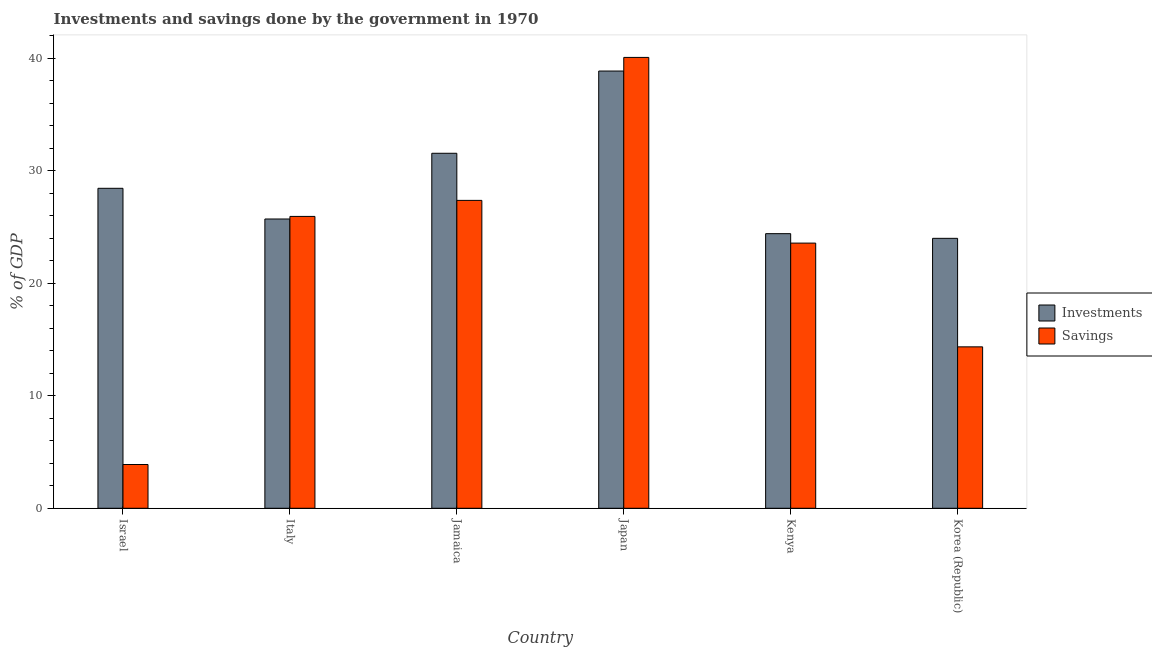How many different coloured bars are there?
Your response must be concise. 2. How many bars are there on the 3rd tick from the right?
Ensure brevity in your answer.  2. What is the label of the 1st group of bars from the left?
Offer a very short reply. Israel. In how many cases, is the number of bars for a given country not equal to the number of legend labels?
Your answer should be compact. 0. What is the savings of government in Japan?
Your answer should be compact. 40.05. Across all countries, what is the maximum savings of government?
Your answer should be very brief. 40.05. Across all countries, what is the minimum savings of government?
Give a very brief answer. 3.89. In which country was the savings of government maximum?
Offer a terse response. Japan. What is the total savings of government in the graph?
Provide a short and direct response. 135.13. What is the difference between the investments of government in Japan and that in Kenya?
Ensure brevity in your answer.  14.45. What is the difference between the investments of government in Japan and the savings of government in Jamaica?
Your answer should be compact. 11.49. What is the average savings of government per country?
Make the answer very short. 22.52. What is the difference between the savings of government and investments of government in Korea (Republic)?
Your response must be concise. -9.64. What is the ratio of the savings of government in Israel to that in Kenya?
Offer a terse response. 0.17. What is the difference between the highest and the second highest investments of government?
Give a very brief answer. 7.31. What is the difference between the highest and the lowest investments of government?
Your answer should be very brief. 14.86. Is the sum of the savings of government in Italy and Kenya greater than the maximum investments of government across all countries?
Make the answer very short. Yes. What does the 1st bar from the left in Kenya represents?
Keep it short and to the point. Investments. What does the 1st bar from the right in Italy represents?
Give a very brief answer. Savings. How many bars are there?
Your answer should be very brief. 12. Are all the bars in the graph horizontal?
Offer a very short reply. No. How many countries are there in the graph?
Your answer should be very brief. 6. Are the values on the major ticks of Y-axis written in scientific E-notation?
Your answer should be very brief. No. How are the legend labels stacked?
Offer a terse response. Vertical. What is the title of the graph?
Provide a succinct answer. Investments and savings done by the government in 1970. What is the label or title of the Y-axis?
Your answer should be very brief. % of GDP. What is the % of GDP in Investments in Israel?
Ensure brevity in your answer.  28.43. What is the % of GDP in Savings in Israel?
Offer a very short reply. 3.89. What is the % of GDP of Investments in Italy?
Your response must be concise. 25.7. What is the % of GDP of Savings in Italy?
Provide a short and direct response. 25.93. What is the % of GDP of Investments in Jamaica?
Keep it short and to the point. 31.54. What is the % of GDP in Savings in Jamaica?
Ensure brevity in your answer.  27.35. What is the % of GDP of Investments in Japan?
Offer a very short reply. 38.84. What is the % of GDP in Savings in Japan?
Keep it short and to the point. 40.05. What is the % of GDP in Investments in Kenya?
Ensure brevity in your answer.  24.4. What is the % of GDP in Savings in Kenya?
Offer a terse response. 23.56. What is the % of GDP in Investments in Korea (Republic)?
Give a very brief answer. 23.98. What is the % of GDP in Savings in Korea (Republic)?
Ensure brevity in your answer.  14.34. Across all countries, what is the maximum % of GDP in Investments?
Keep it short and to the point. 38.84. Across all countries, what is the maximum % of GDP of Savings?
Make the answer very short. 40.05. Across all countries, what is the minimum % of GDP of Investments?
Offer a terse response. 23.98. Across all countries, what is the minimum % of GDP in Savings?
Offer a very short reply. 3.89. What is the total % of GDP of Investments in the graph?
Your response must be concise. 172.89. What is the total % of GDP of Savings in the graph?
Make the answer very short. 135.13. What is the difference between the % of GDP in Investments in Israel and that in Italy?
Your answer should be very brief. 2.73. What is the difference between the % of GDP of Savings in Israel and that in Italy?
Offer a very short reply. -22.04. What is the difference between the % of GDP in Investments in Israel and that in Jamaica?
Offer a terse response. -3.11. What is the difference between the % of GDP in Savings in Israel and that in Jamaica?
Offer a very short reply. -23.47. What is the difference between the % of GDP of Investments in Israel and that in Japan?
Keep it short and to the point. -10.42. What is the difference between the % of GDP of Savings in Israel and that in Japan?
Provide a short and direct response. -36.17. What is the difference between the % of GDP of Investments in Israel and that in Kenya?
Your response must be concise. 4.03. What is the difference between the % of GDP of Savings in Israel and that in Kenya?
Make the answer very short. -19.67. What is the difference between the % of GDP in Investments in Israel and that in Korea (Republic)?
Give a very brief answer. 4.45. What is the difference between the % of GDP of Savings in Israel and that in Korea (Republic)?
Provide a succinct answer. -10.45. What is the difference between the % of GDP of Investments in Italy and that in Jamaica?
Provide a succinct answer. -5.84. What is the difference between the % of GDP of Savings in Italy and that in Jamaica?
Give a very brief answer. -1.42. What is the difference between the % of GDP in Investments in Italy and that in Japan?
Provide a short and direct response. -13.14. What is the difference between the % of GDP of Savings in Italy and that in Japan?
Your answer should be very brief. -14.12. What is the difference between the % of GDP in Investments in Italy and that in Kenya?
Provide a succinct answer. 1.3. What is the difference between the % of GDP of Savings in Italy and that in Kenya?
Offer a very short reply. 2.37. What is the difference between the % of GDP of Investments in Italy and that in Korea (Republic)?
Provide a succinct answer. 1.72. What is the difference between the % of GDP of Savings in Italy and that in Korea (Republic)?
Ensure brevity in your answer.  11.59. What is the difference between the % of GDP of Investments in Jamaica and that in Japan?
Keep it short and to the point. -7.31. What is the difference between the % of GDP of Savings in Jamaica and that in Japan?
Offer a very short reply. -12.7. What is the difference between the % of GDP of Investments in Jamaica and that in Kenya?
Offer a very short reply. 7.14. What is the difference between the % of GDP in Savings in Jamaica and that in Kenya?
Your answer should be very brief. 3.79. What is the difference between the % of GDP of Investments in Jamaica and that in Korea (Republic)?
Give a very brief answer. 7.56. What is the difference between the % of GDP of Savings in Jamaica and that in Korea (Republic)?
Offer a very short reply. 13.01. What is the difference between the % of GDP of Investments in Japan and that in Kenya?
Keep it short and to the point. 14.45. What is the difference between the % of GDP in Savings in Japan and that in Kenya?
Provide a short and direct response. 16.5. What is the difference between the % of GDP of Investments in Japan and that in Korea (Republic)?
Provide a short and direct response. 14.86. What is the difference between the % of GDP in Savings in Japan and that in Korea (Republic)?
Give a very brief answer. 25.71. What is the difference between the % of GDP in Investments in Kenya and that in Korea (Republic)?
Offer a very short reply. 0.42. What is the difference between the % of GDP in Savings in Kenya and that in Korea (Republic)?
Offer a terse response. 9.22. What is the difference between the % of GDP of Investments in Israel and the % of GDP of Savings in Italy?
Provide a short and direct response. 2.5. What is the difference between the % of GDP in Investments in Israel and the % of GDP in Savings in Jamaica?
Give a very brief answer. 1.07. What is the difference between the % of GDP of Investments in Israel and the % of GDP of Savings in Japan?
Your answer should be very brief. -11.63. What is the difference between the % of GDP of Investments in Israel and the % of GDP of Savings in Kenya?
Provide a succinct answer. 4.87. What is the difference between the % of GDP of Investments in Israel and the % of GDP of Savings in Korea (Republic)?
Your answer should be compact. 14.08. What is the difference between the % of GDP in Investments in Italy and the % of GDP in Savings in Jamaica?
Provide a short and direct response. -1.65. What is the difference between the % of GDP of Investments in Italy and the % of GDP of Savings in Japan?
Ensure brevity in your answer.  -14.36. What is the difference between the % of GDP in Investments in Italy and the % of GDP in Savings in Kenya?
Your answer should be compact. 2.14. What is the difference between the % of GDP in Investments in Italy and the % of GDP in Savings in Korea (Republic)?
Ensure brevity in your answer.  11.36. What is the difference between the % of GDP of Investments in Jamaica and the % of GDP of Savings in Japan?
Make the answer very short. -8.52. What is the difference between the % of GDP of Investments in Jamaica and the % of GDP of Savings in Kenya?
Keep it short and to the point. 7.98. What is the difference between the % of GDP in Investments in Jamaica and the % of GDP in Savings in Korea (Republic)?
Your answer should be compact. 17.2. What is the difference between the % of GDP of Investments in Japan and the % of GDP of Savings in Kenya?
Ensure brevity in your answer.  15.29. What is the difference between the % of GDP in Investments in Japan and the % of GDP in Savings in Korea (Republic)?
Offer a terse response. 24.5. What is the difference between the % of GDP of Investments in Kenya and the % of GDP of Savings in Korea (Republic)?
Give a very brief answer. 10.06. What is the average % of GDP of Investments per country?
Give a very brief answer. 28.81. What is the average % of GDP in Savings per country?
Your answer should be compact. 22.52. What is the difference between the % of GDP in Investments and % of GDP in Savings in Israel?
Your answer should be very brief. 24.54. What is the difference between the % of GDP of Investments and % of GDP of Savings in Italy?
Give a very brief answer. -0.23. What is the difference between the % of GDP in Investments and % of GDP in Savings in Jamaica?
Your response must be concise. 4.19. What is the difference between the % of GDP of Investments and % of GDP of Savings in Japan?
Your answer should be very brief. -1.21. What is the difference between the % of GDP of Investments and % of GDP of Savings in Kenya?
Make the answer very short. 0.84. What is the difference between the % of GDP in Investments and % of GDP in Savings in Korea (Republic)?
Your response must be concise. 9.64. What is the ratio of the % of GDP of Investments in Israel to that in Italy?
Make the answer very short. 1.11. What is the ratio of the % of GDP in Savings in Israel to that in Italy?
Your answer should be compact. 0.15. What is the ratio of the % of GDP in Investments in Israel to that in Jamaica?
Ensure brevity in your answer.  0.9. What is the ratio of the % of GDP of Savings in Israel to that in Jamaica?
Make the answer very short. 0.14. What is the ratio of the % of GDP in Investments in Israel to that in Japan?
Offer a very short reply. 0.73. What is the ratio of the % of GDP of Savings in Israel to that in Japan?
Provide a short and direct response. 0.1. What is the ratio of the % of GDP in Investments in Israel to that in Kenya?
Your answer should be compact. 1.17. What is the ratio of the % of GDP of Savings in Israel to that in Kenya?
Keep it short and to the point. 0.17. What is the ratio of the % of GDP of Investments in Israel to that in Korea (Republic)?
Your answer should be very brief. 1.19. What is the ratio of the % of GDP in Savings in Israel to that in Korea (Republic)?
Offer a terse response. 0.27. What is the ratio of the % of GDP in Investments in Italy to that in Jamaica?
Provide a short and direct response. 0.81. What is the ratio of the % of GDP in Savings in Italy to that in Jamaica?
Keep it short and to the point. 0.95. What is the ratio of the % of GDP in Investments in Italy to that in Japan?
Offer a very short reply. 0.66. What is the ratio of the % of GDP of Savings in Italy to that in Japan?
Offer a very short reply. 0.65. What is the ratio of the % of GDP of Investments in Italy to that in Kenya?
Give a very brief answer. 1.05. What is the ratio of the % of GDP of Savings in Italy to that in Kenya?
Your answer should be very brief. 1.1. What is the ratio of the % of GDP of Investments in Italy to that in Korea (Republic)?
Provide a succinct answer. 1.07. What is the ratio of the % of GDP of Savings in Italy to that in Korea (Republic)?
Ensure brevity in your answer.  1.81. What is the ratio of the % of GDP of Investments in Jamaica to that in Japan?
Your answer should be very brief. 0.81. What is the ratio of the % of GDP in Savings in Jamaica to that in Japan?
Give a very brief answer. 0.68. What is the ratio of the % of GDP of Investments in Jamaica to that in Kenya?
Provide a succinct answer. 1.29. What is the ratio of the % of GDP in Savings in Jamaica to that in Kenya?
Offer a terse response. 1.16. What is the ratio of the % of GDP of Investments in Jamaica to that in Korea (Republic)?
Your answer should be very brief. 1.32. What is the ratio of the % of GDP of Savings in Jamaica to that in Korea (Republic)?
Your answer should be very brief. 1.91. What is the ratio of the % of GDP in Investments in Japan to that in Kenya?
Make the answer very short. 1.59. What is the ratio of the % of GDP of Savings in Japan to that in Kenya?
Ensure brevity in your answer.  1.7. What is the ratio of the % of GDP of Investments in Japan to that in Korea (Republic)?
Your answer should be compact. 1.62. What is the ratio of the % of GDP in Savings in Japan to that in Korea (Republic)?
Give a very brief answer. 2.79. What is the ratio of the % of GDP of Investments in Kenya to that in Korea (Republic)?
Ensure brevity in your answer.  1.02. What is the ratio of the % of GDP in Savings in Kenya to that in Korea (Republic)?
Offer a very short reply. 1.64. What is the difference between the highest and the second highest % of GDP of Investments?
Offer a very short reply. 7.31. What is the difference between the highest and the second highest % of GDP of Savings?
Your answer should be compact. 12.7. What is the difference between the highest and the lowest % of GDP in Investments?
Your response must be concise. 14.86. What is the difference between the highest and the lowest % of GDP of Savings?
Offer a terse response. 36.17. 